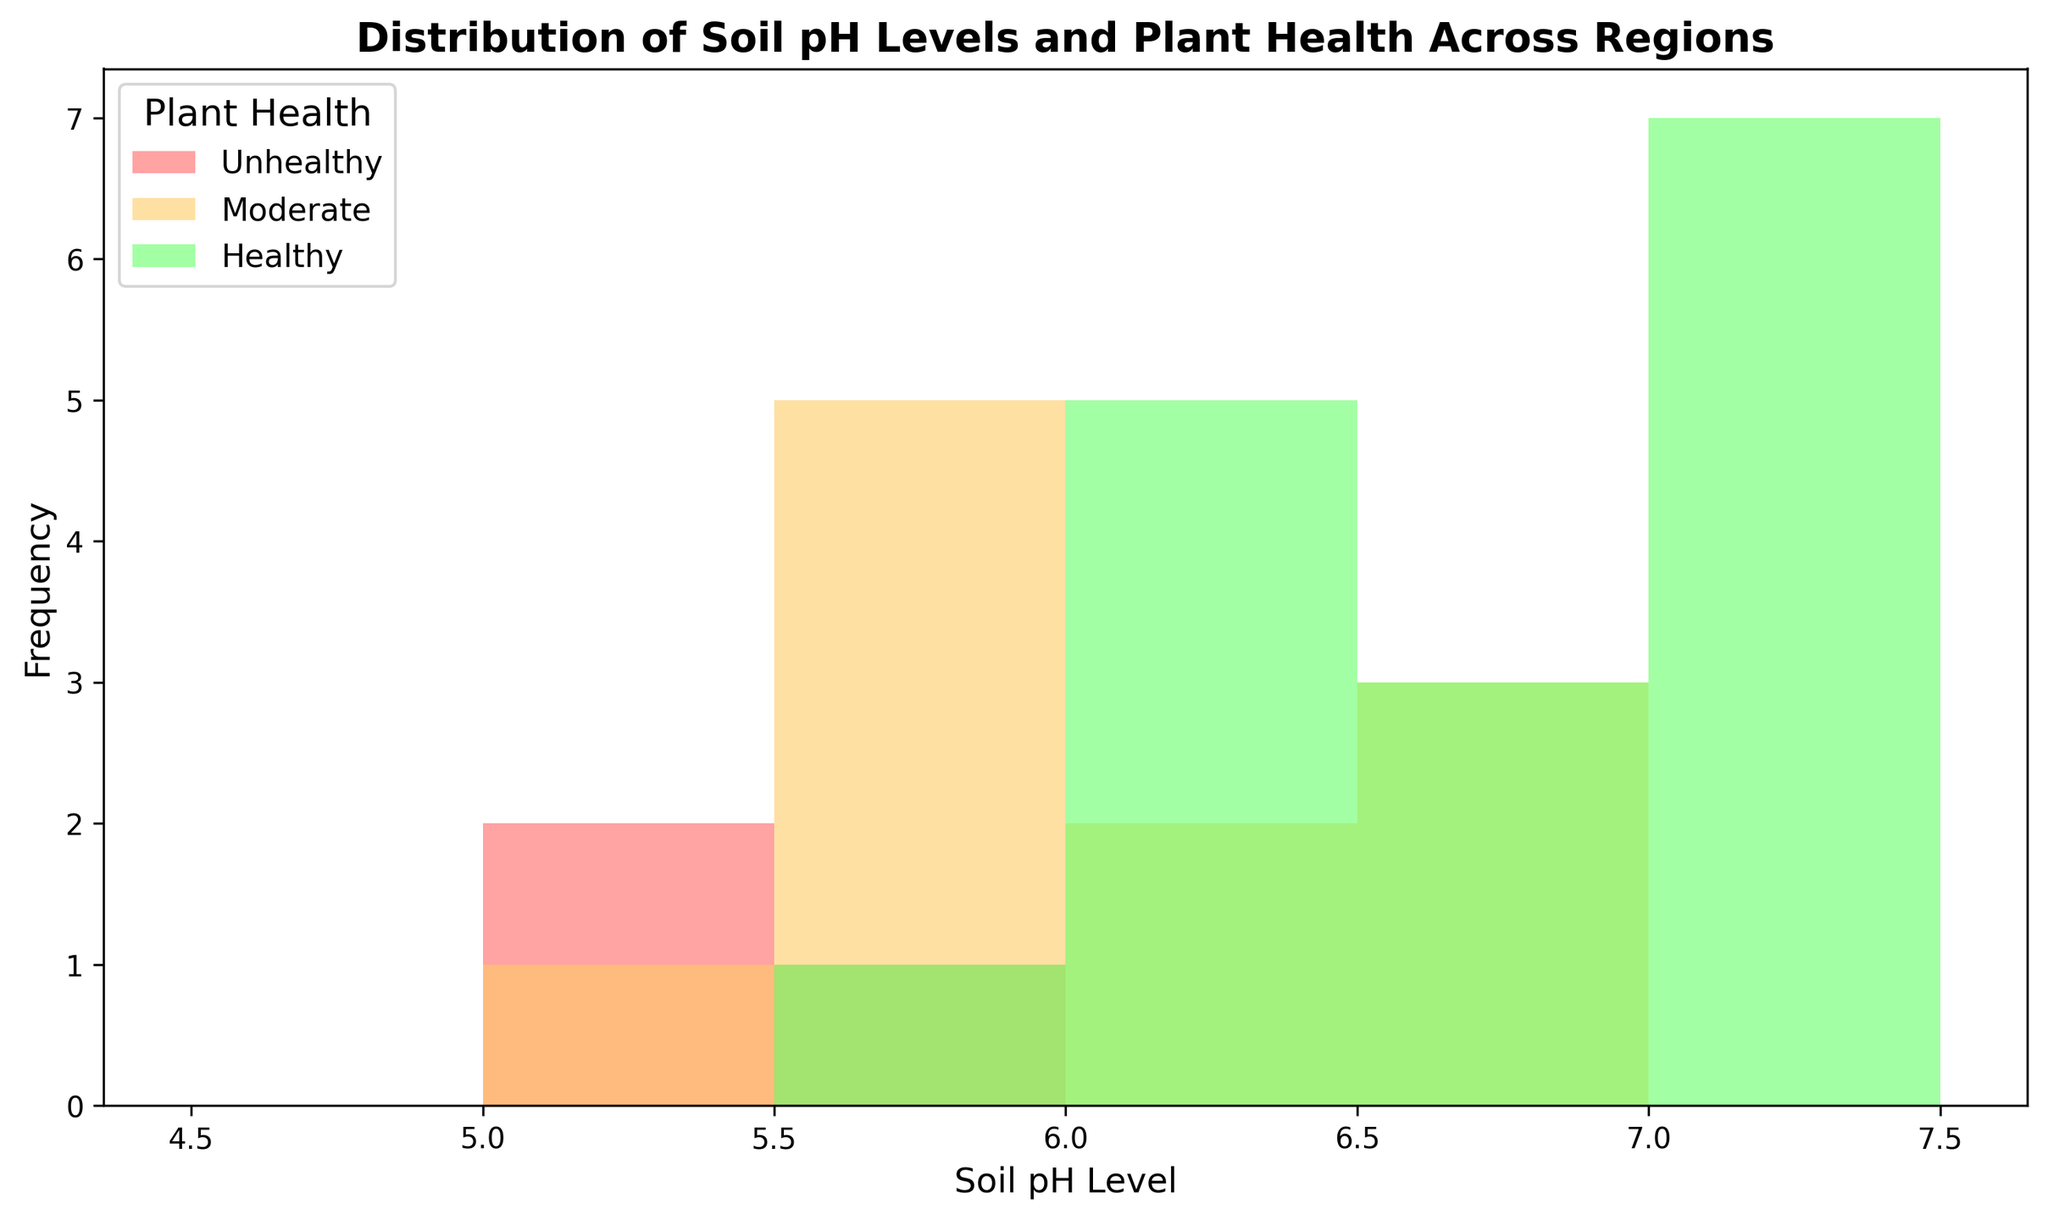What soil pH level has the highest frequency in the histogram? To determine the highest frequency, look at the bars' heights and identify which soil pH level corresponds to the tallest bar.
Answer: 5.7 What is the most prevalent plant health category in the histogram? Assess the color distribution of the bars in the chart. Each color represents a plant health category, and the predominant color reveals the most prevalent category.
Answer: Healthy How many regions have a soil pH range between 6.0 and 6.5? Examine the bins for the 6.0 to 6.5 range and count the bars. Each bar represents a specific frequency of soil pH levels within that range.
Answer: 5 Which plant health category is most common at a soil pH level of 5.5? Identify the bar corresponding to a soil pH of 5.5 and check its color to determine the plant health category it represents.
Answer: Unhealthy Is there a noticeable trend in plant health as soil pH levels change? Observe the histogram to see if there is a pattern between soil pH levels and the frequency of each plant health category. Typically, certain pH ranges correlate with higher frequencies of specific health categories.
Answer: Yes, healthier plants generally appear at pH levels above 6.0 What soil pH levels are most common in regions with moderately healthy plants? Identify the yellow-colored bars that represent moderate plant health and note the corresponding soil pH levels.
Answer: 5.7, 5.8, 5.9, 6.0, 6.9, 6.8 Which soil pH level shows the least variation in plant health categories? Look for a soil pH level where the bars are mostly one color, indicating a lack of variation in the associated plant health categories.
Answer: 7.5 Are there any soil pH levels completely lacking healthy plants? Determine if any of the soil pH levels' bars do not include the green color that denotes healthy plants.
Answer: 5.3, 5.5 